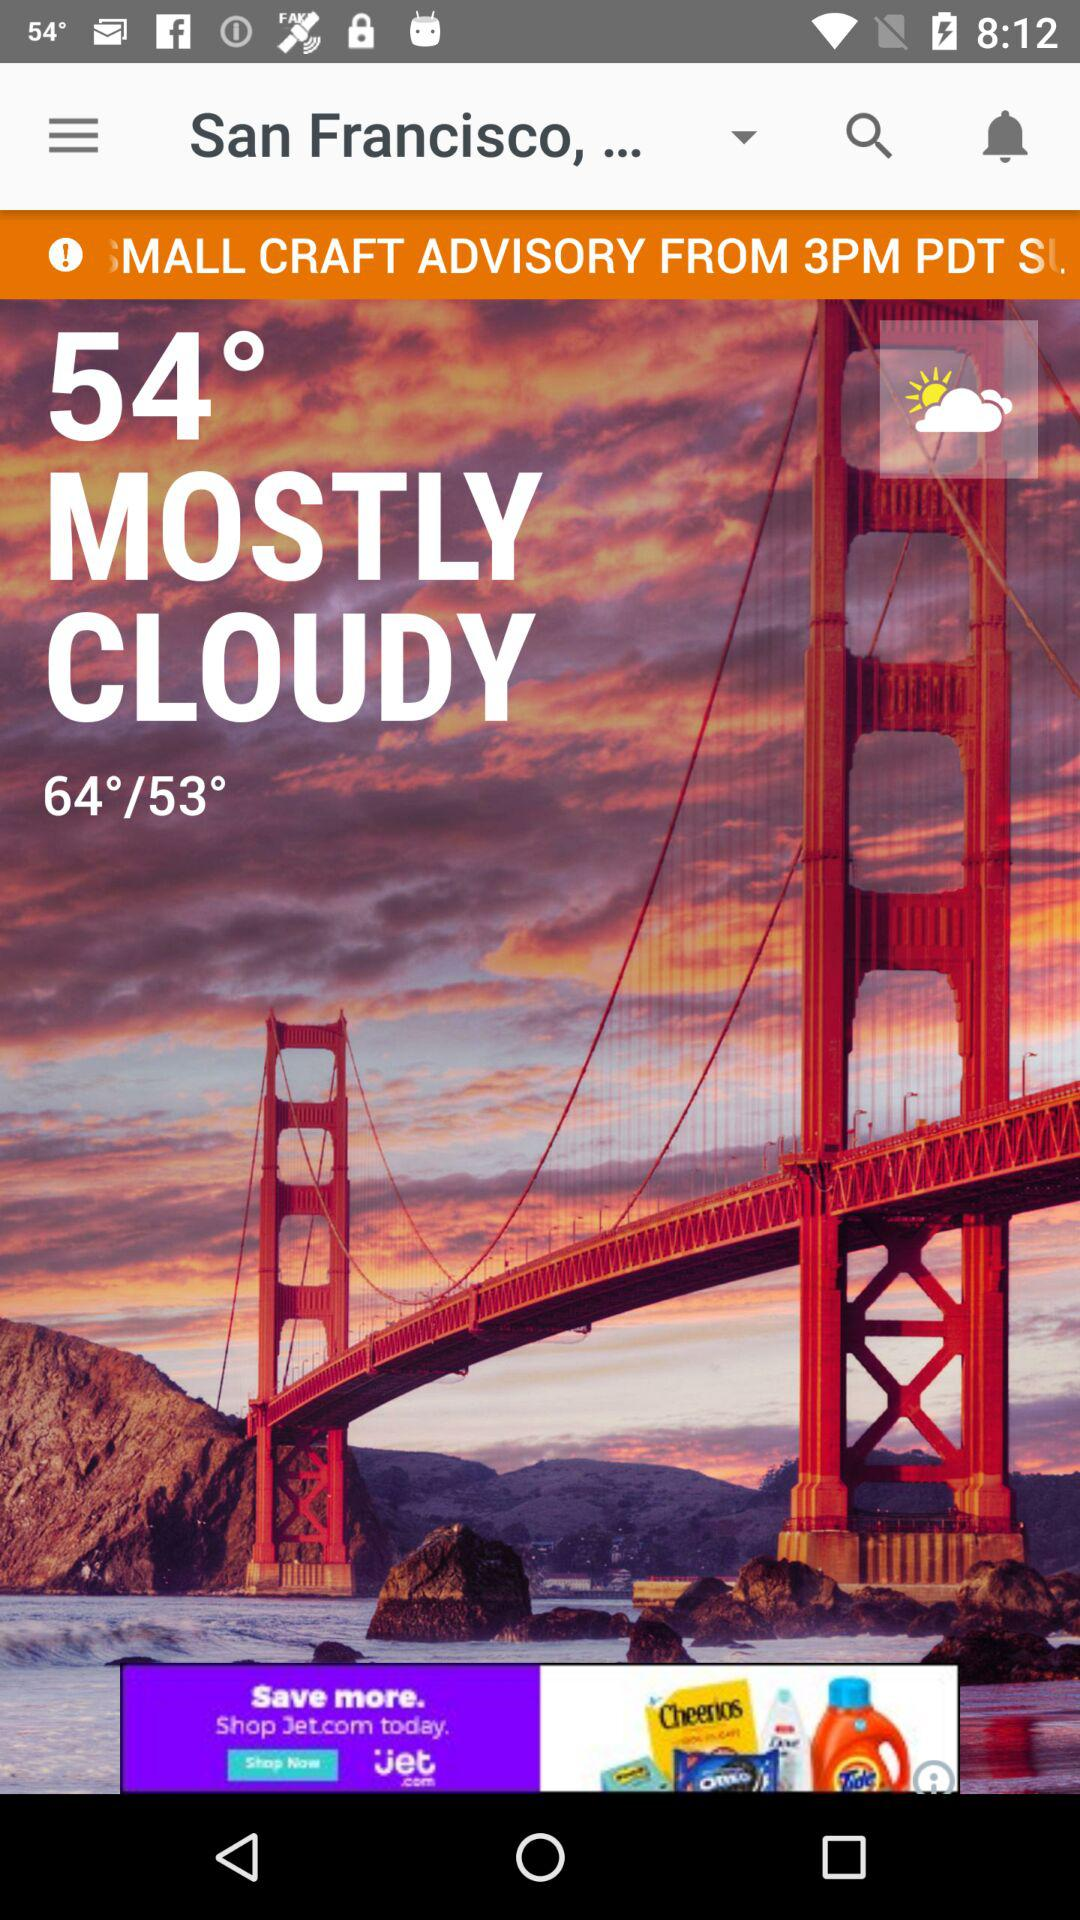How many degrees higher is the high temperature than the low temperature?
Answer the question using a single word or phrase. 11 